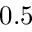<formula> <loc_0><loc_0><loc_500><loc_500>0 . 5</formula> 